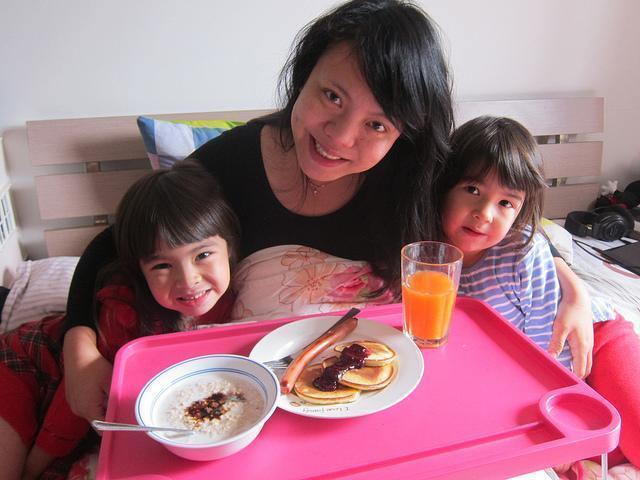How do these people know each other?
Choose the right answer from the provided options to respond to the question.
Options: Teammates, coworkers, family, classmates. Family. 